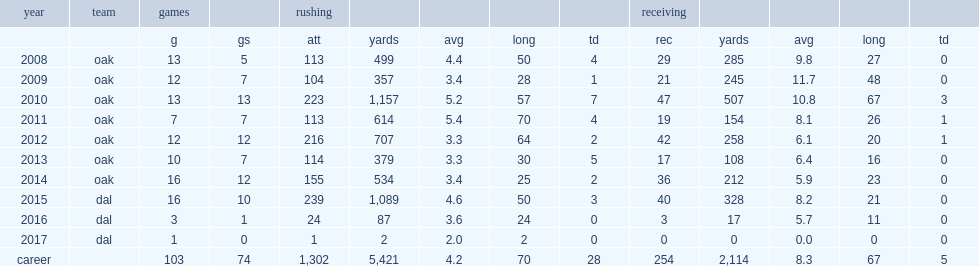How many games did mcfadden appear in the 2013 season? 10.0. 